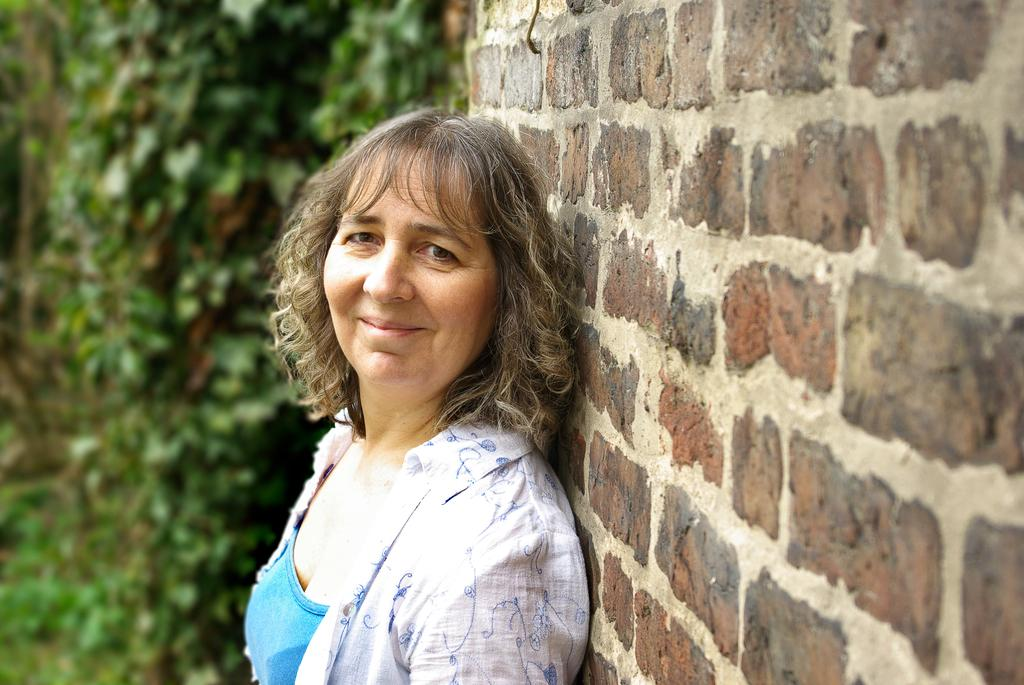Who is present in the image? There is a woman in the image. What is the woman wearing? The woman is wearing a blue and white dress. Where is the woman standing in the image? The woman is standing near a brick wall. What can be seen in the background of the image? There are plants in the background of the image. What type of wristwatch is the woman wearing in the image? There is no wristwatch visible in the image; the woman is wearing a blue and white dress. What book is the woman holding in the image? There is no book present in the image; the woman is standing near a brick wall. 